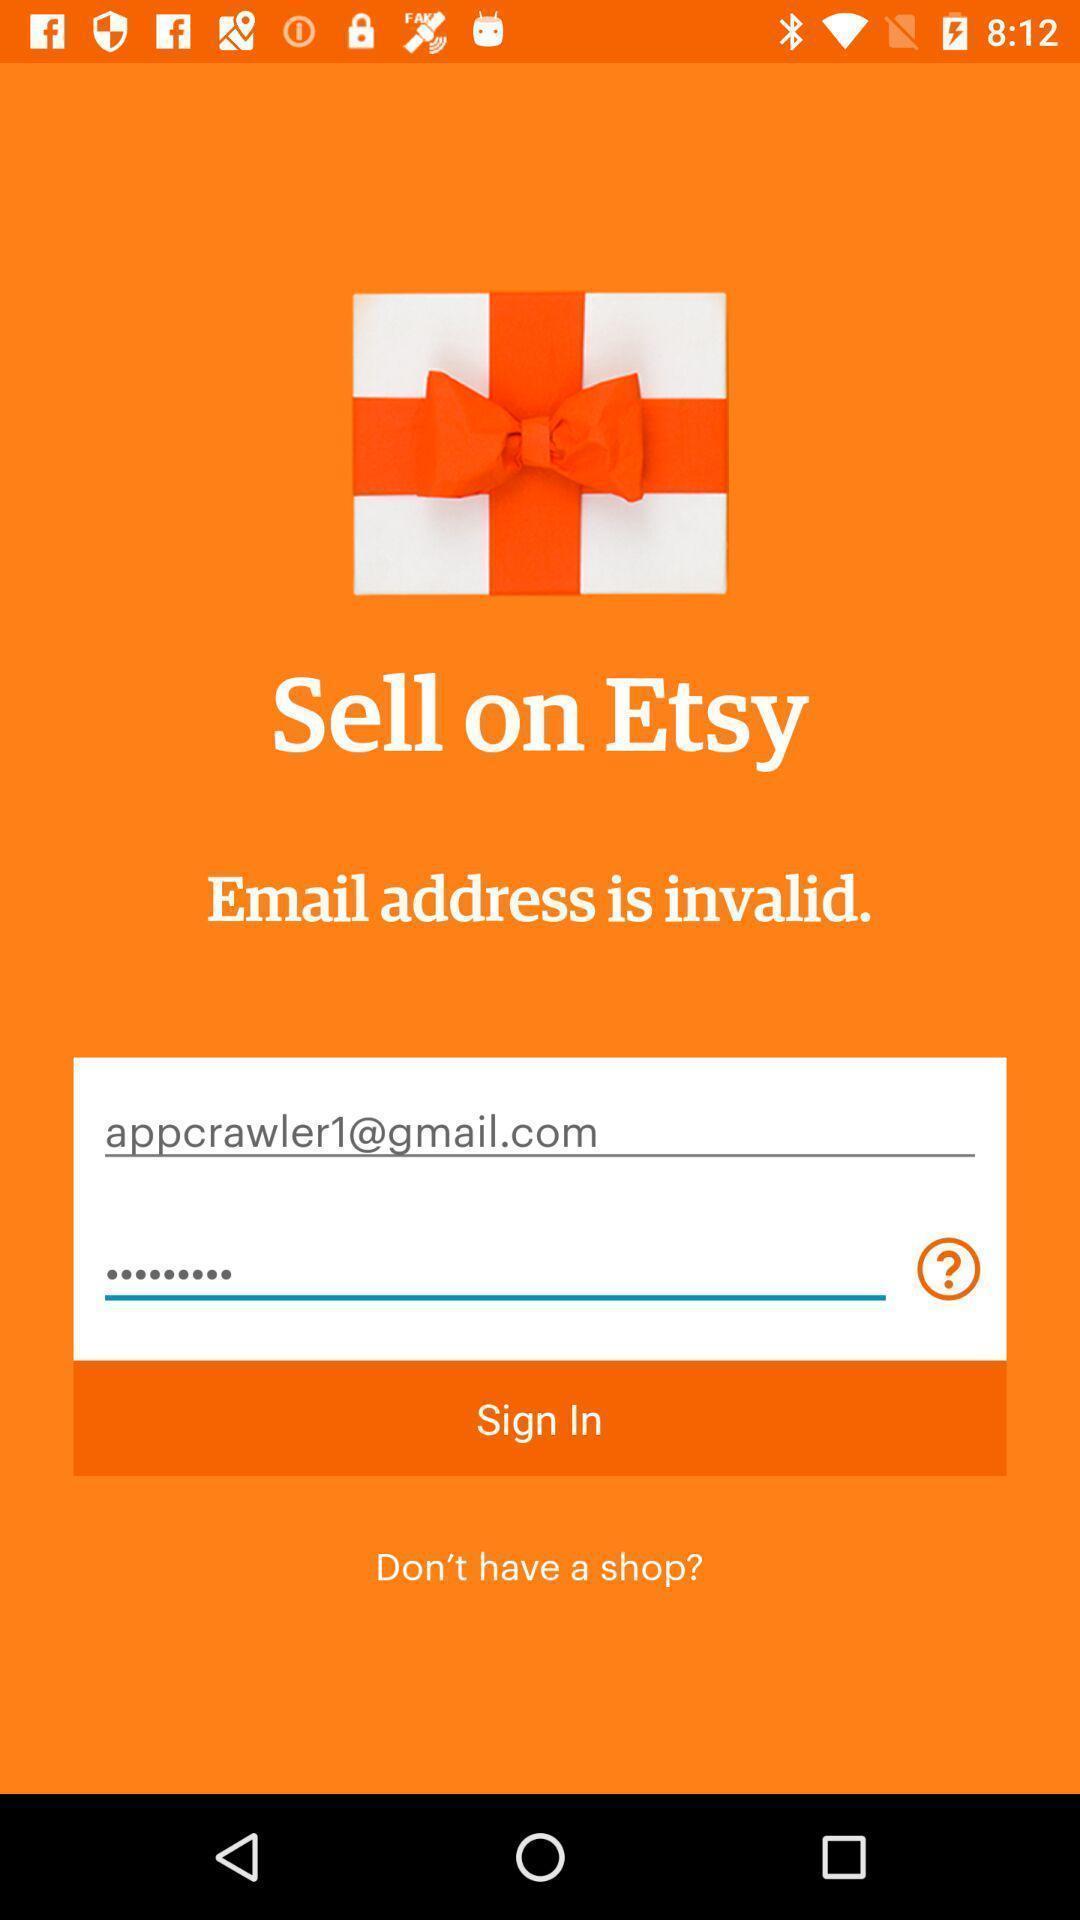Explain the elements present in this screenshot. Sign in page. 